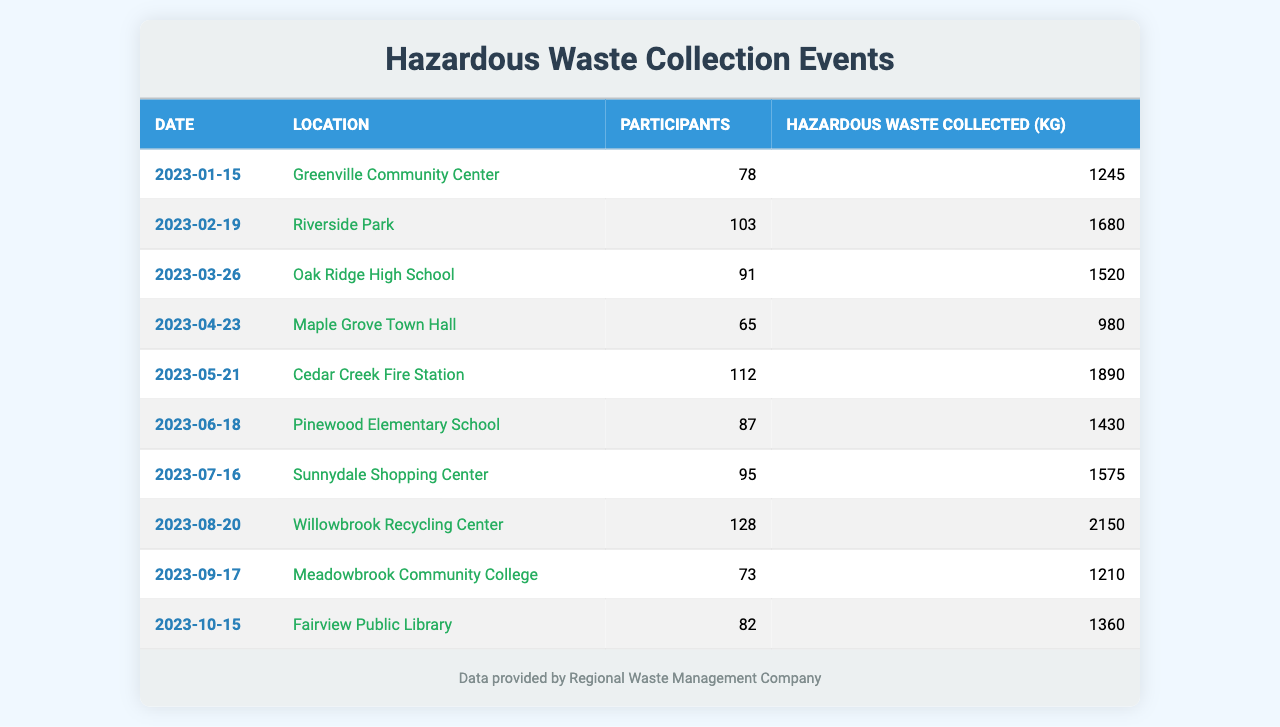What was the highest number of participants in a single event? The event with the highest number of participants is on August 20, 2023, at Willowbrook Recycling Center, which had 128 participants.
Answer: 128 What was the total amount of hazardous waste collected over all events? To find the total, sum all the kilograms of hazardous waste collected: 1245 + 1680 + 1520 + 980 + 1890 + 1430 + 1575 + 2150 + 1210 + 1360 = 13970 kg.
Answer: 13970 kg Which event had the lowest participation? The event with the lowest number of participants was on April 23, 2023, at Maple Grove Town Hall, with 65 participants.
Answer: 65 On which date was the most hazardous waste collected, and how much was it? The event with the most hazardous waste collected occurred on August 20, 2023, at Willowbrook Recycling Center, with 2150 kg of hazardous waste.
Answer: August 20, 2023, 2150 kg What is the average number of participants across all events? To calculate the average, sum the participants: 78 + 103 + 91 + 65 + 112 + 87 + 95 + 128 + 73 + 82 = 1010. Then divide by the number of events (10): 1010 / 10 = 101.
Answer: 101 Was there ever an event with more than 100 participants, and if so, how many times did that happen? Yes, there were five events with more than 100 participants: February (103), May (112), August (128).
Answer: Yes, 5 times What was the difference in hazardous waste collected between the highest and lowest event? The highest amount collected was 2150 kg on August 20, and the lowest was 980 kg on April 23. The difference is 2150 - 980 = 1170 kg.
Answer: 1170 kg Which location had the second highest participation? The second highest participation occurred at Cedar Creek Fire Station on May 21, 2023, with 112 participants.
Answer: Cedar Creek Fire Station How many events had participation levels below 80? There are three events with participation below 80: January (78), April (65), and September (73).
Answer: 3 events Was there a consistent increase in the amount of hazardous waste collected each month? No, the amount collected varied each month with both increases and decreases; for example, April had a decrease compared to March.
Answer: No 